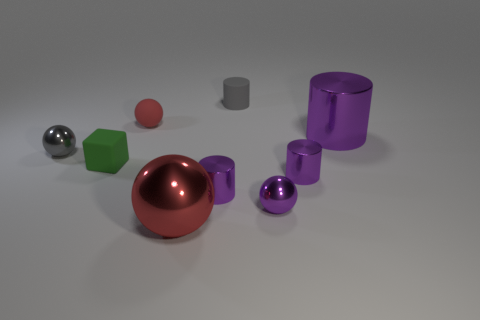Subtract all tiny red spheres. How many spheres are left? 3 Subtract all blue blocks. How many red balls are left? 2 Add 1 gray objects. How many objects exist? 10 Subtract all purple cylinders. How many cylinders are left? 1 Subtract all spheres. How many objects are left? 5 Subtract 1 blocks. How many blocks are left? 0 Subtract all yellow blocks. Subtract all brown spheres. How many blocks are left? 1 Subtract all green matte blocks. Subtract all tiny purple metallic balls. How many objects are left? 7 Add 7 red shiny objects. How many red shiny objects are left? 8 Add 7 tiny metallic cylinders. How many tiny metallic cylinders exist? 9 